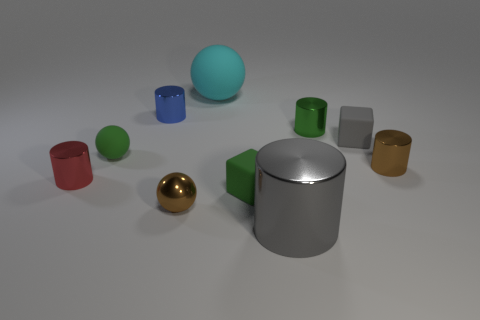Subtract 1 cylinders. How many cylinders are left? 4 Subtract all large gray cylinders. How many cylinders are left? 4 Subtract all gray cylinders. How many cylinders are left? 4 Subtract all yellow cylinders. Subtract all green blocks. How many cylinders are left? 5 Subtract all cubes. How many objects are left? 8 Add 5 matte things. How many matte things are left? 9 Add 1 big brown rubber objects. How many big brown rubber objects exist? 1 Subtract 0 blue cubes. How many objects are left? 10 Subtract all blue rubber balls. Subtract all green cylinders. How many objects are left? 9 